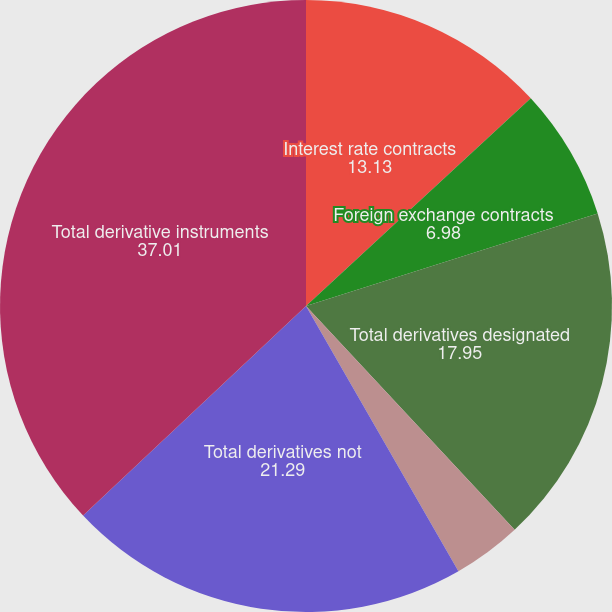<chart> <loc_0><loc_0><loc_500><loc_500><pie_chart><fcel>Interest rate contracts<fcel>Foreign exchange contracts<fcel>Total derivatives designated<fcel>Credit contracts<fcel>Total derivatives not<fcel>Total derivative instruments<nl><fcel>13.13%<fcel>6.98%<fcel>17.95%<fcel>3.64%<fcel>21.29%<fcel>37.01%<nl></chart> 